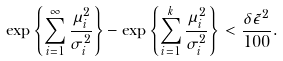Convert formula to latex. <formula><loc_0><loc_0><loc_500><loc_500>\exp \left \{ \sum _ { i = 1 } ^ { \infty } \frac { \mu _ { i } ^ { 2 } } { \sigma _ { i } ^ { 2 } } \right \} - \exp \left \{ \sum _ { i = 1 } ^ { k } \frac { \mu _ { i } ^ { 2 } } { \sigma _ { i } ^ { 2 } } \right \} < \frac { \delta \tilde { \epsilon } ^ { 2 } } { 1 0 0 } .</formula> 